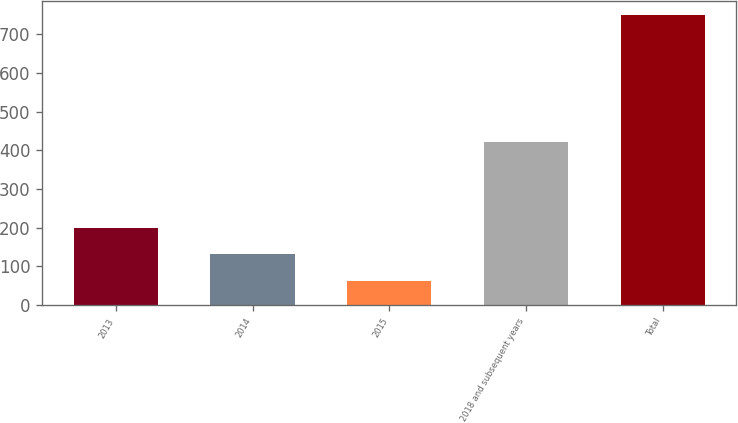Convert chart to OTSL. <chart><loc_0><loc_0><loc_500><loc_500><bar_chart><fcel>2013<fcel>2014<fcel>2015<fcel>2018 and subsequent years<fcel>Total<nl><fcel>200.2<fcel>131.6<fcel>63<fcel>422<fcel>749<nl></chart> 